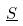Convert formula to latex. <formula><loc_0><loc_0><loc_500><loc_500>\underline { S }</formula> 